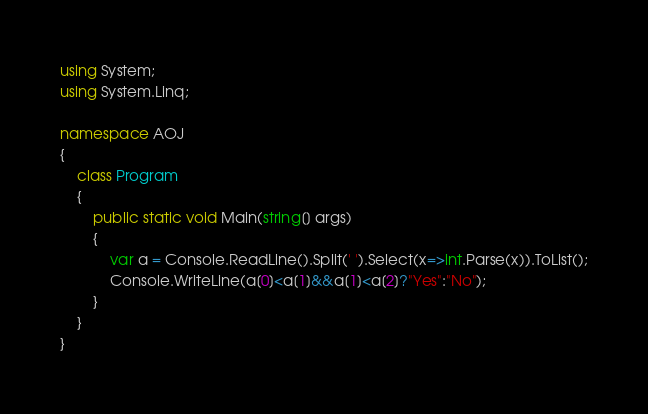Convert code to text. <code><loc_0><loc_0><loc_500><loc_500><_C#_>using System;
using System.Linq;

namespace AOJ
{
	class Program
	{
		public static void Main(string[] args)
		{
			var a = Console.ReadLine().Split(' ').Select(x=>int.Parse(x)).ToList();
			Console.WriteLine(a[0]<a[1]&&a[1]<a[2]?"Yes":"No");
		}
	}
}</code> 